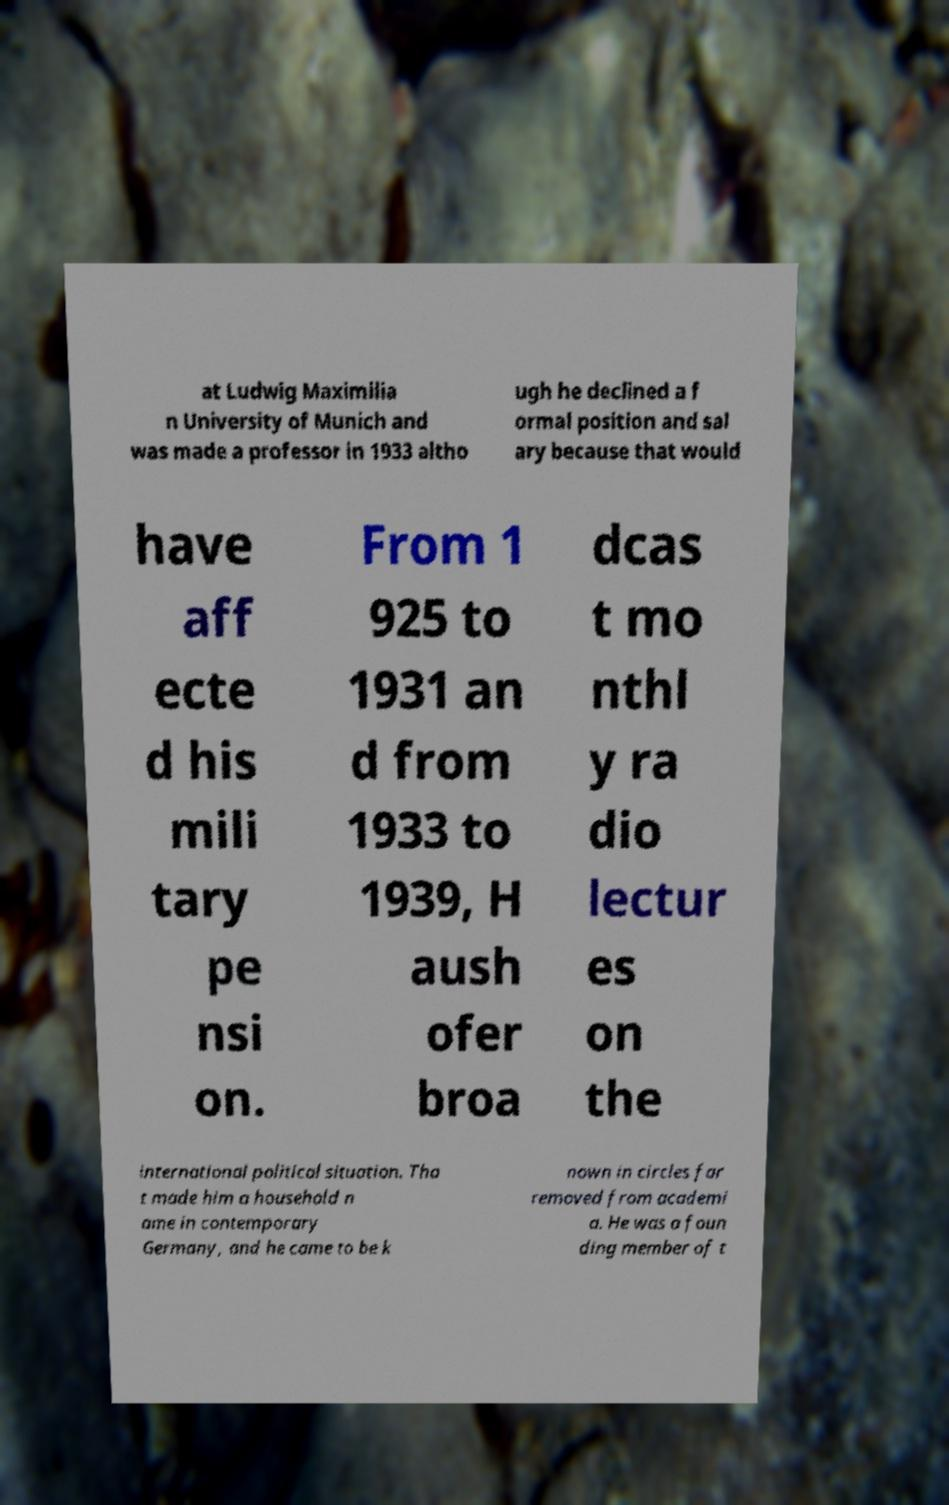What messages or text are displayed in this image? I need them in a readable, typed format. at Ludwig Maximilia n University of Munich and was made a professor in 1933 altho ugh he declined a f ormal position and sal ary because that would have aff ecte d his mili tary pe nsi on. From 1 925 to 1931 an d from 1933 to 1939, H aush ofer broa dcas t mo nthl y ra dio lectur es on the international political situation. Tha t made him a household n ame in contemporary Germany, and he came to be k nown in circles far removed from academi a. He was a foun ding member of t 